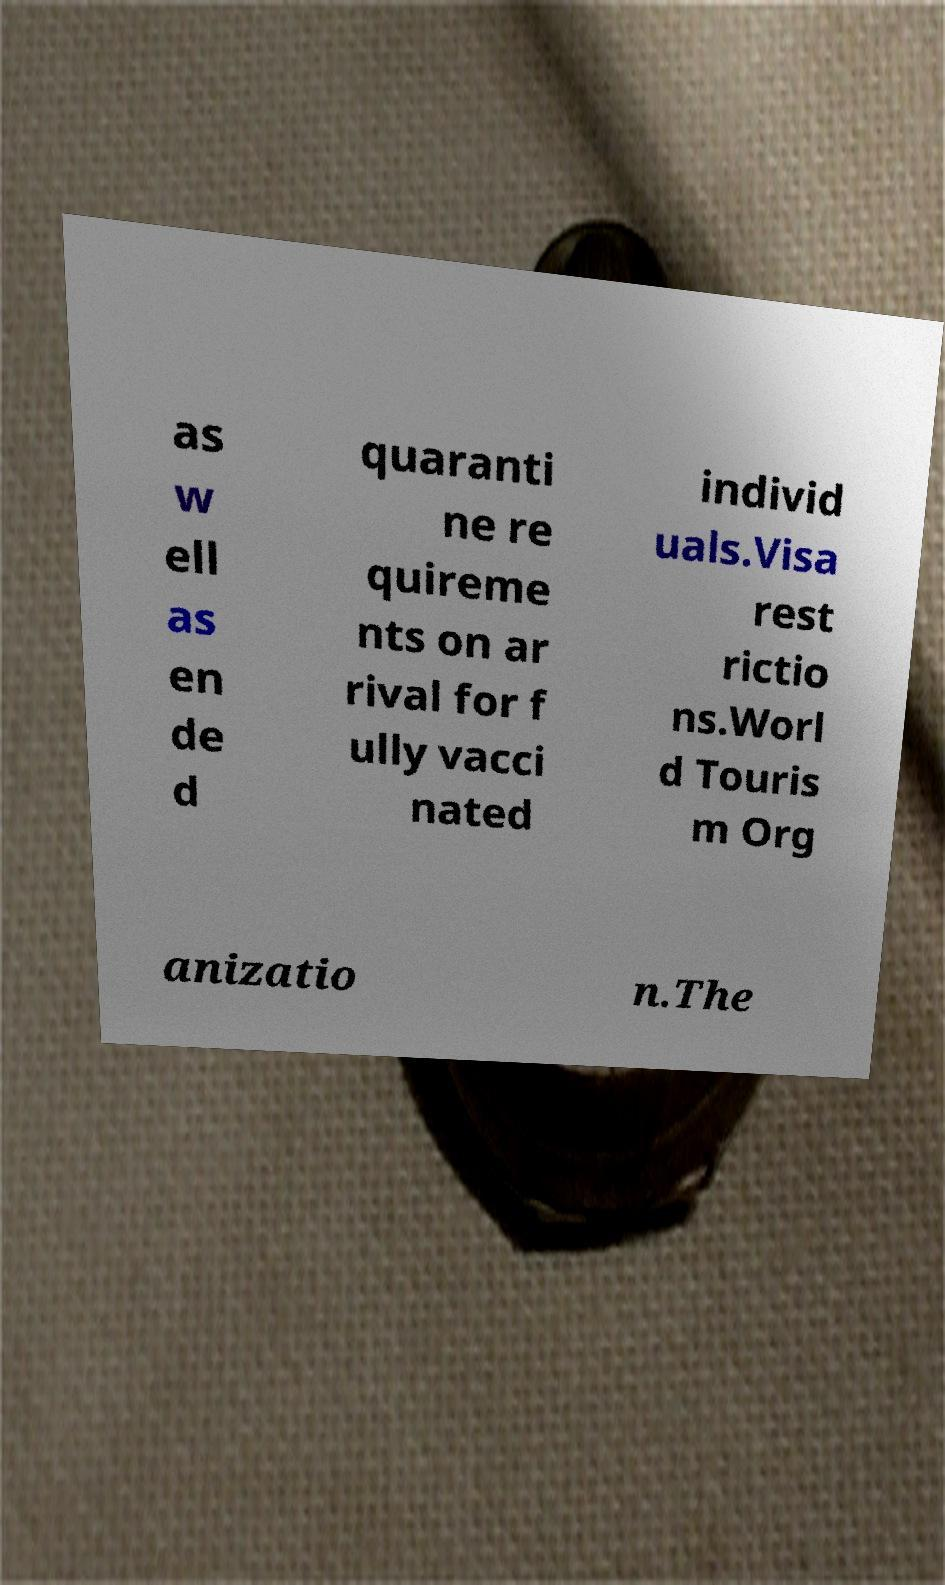For documentation purposes, I need the text within this image transcribed. Could you provide that? as w ell as en de d quaranti ne re quireme nts on ar rival for f ully vacci nated individ uals.Visa rest rictio ns.Worl d Touris m Org anizatio n.The 